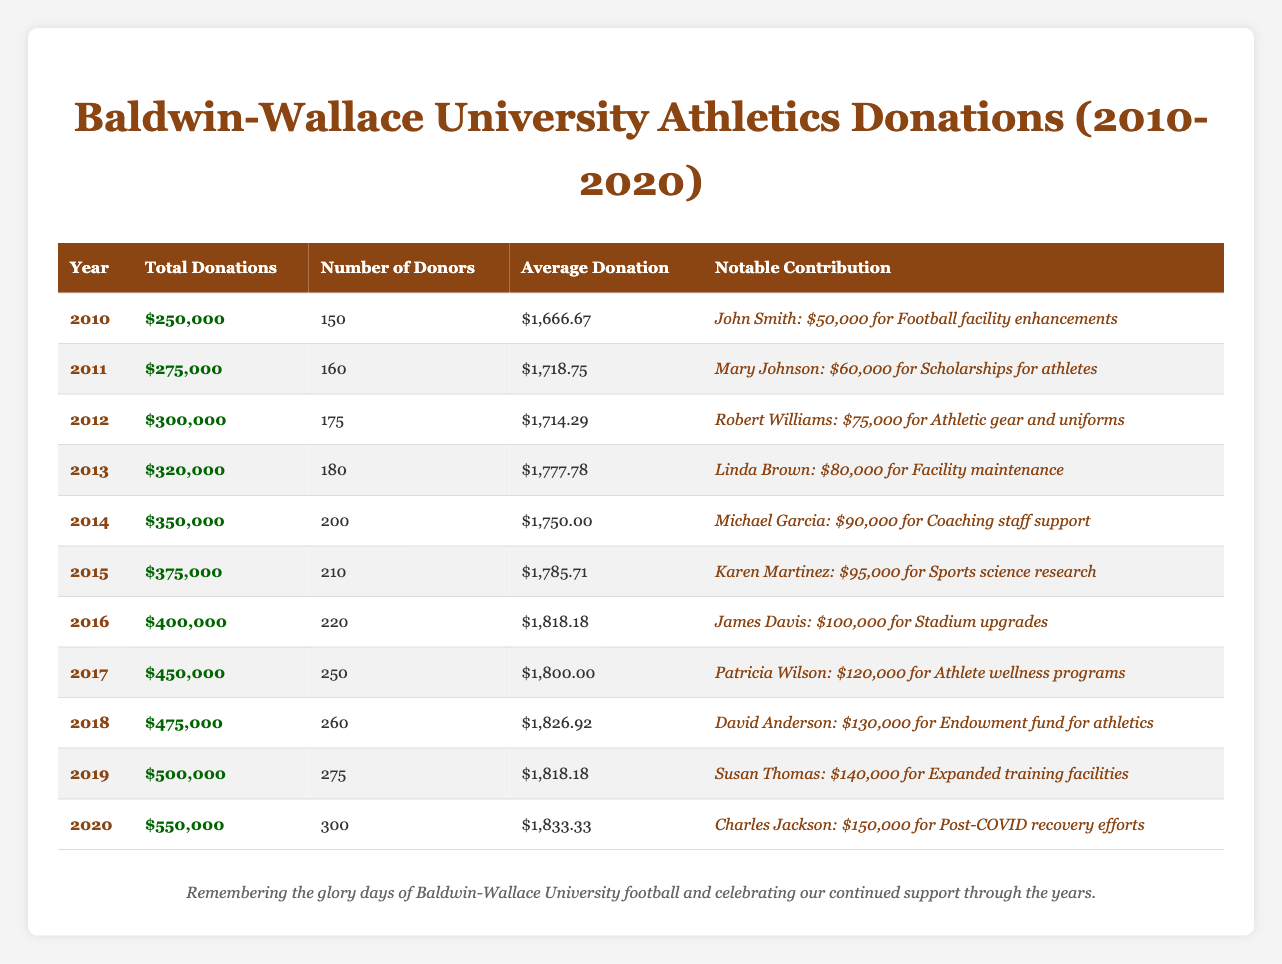What was the total donations in 2015? In the table, I find the row for the year 2015, where the total donations are listed as $375,000.
Answer: $375,000 Which year had the highest average donation amount? I look at the "Average Donation" column and compare the values. The highest average donation is $1,833.33 in 2020.
Answer: $1,833.33 How much did alumni donate in total from 2010 to 2014? I sum the total donations from the years 2010 to 2014: $250,000 + $275,000 + $300,000 + $320,000 + $350,000 = $1,495,000.
Answer: $1,495,000 Was there an increase in the number of donors from 2011 to 2012? I compare the number of donors in 2011, which is 160, and in 2012, which is 175. Since 175 is greater than 160, it indicates an increase.
Answer: Yes What was the total donations in 2019, and who made the notable contribution that year? Referring to the year 2019 in the table, the total donations were $500,000, and the notable contribution was made by Susan Thomas for $140,000.
Answer: $500,000, Susan Thomas Calculate the average number of donors from 2016 to 2020. I take the number of donors from 2016 to 2020: 220, 250, 260, 275, 300. I sum these: 220 + 250 + 260 + 275 + 300 = 1305. Then, I divide by 5: 1305 / 5 = 261.
Answer: 261 Which year had the least total donations, and what was the amount? I search through the total donations column and find that 2010 had the least total donations at $250,000.
Answer: 2010, $250,000 What percentage increase in total donations occurred from 2018 to 2020? I find the total donations for 2018, which is $475,000, and for 2020, which is $550,000. I calculate the increase: $550,000 - $475,000 = $75,000. The percentage increase is ($75,000 / $475,000) * 100 ≈ 15.79%.
Answer: Approximately 15.79% What notable contribution was made for coaching staff support, and who was the donor? Referring to the year 2014 in the table, the notable contribution for coaching staff support was made by Michael Garcia, amounting to $90,000.
Answer: Michael Garcia, $90,000 How much more in total donations did Baldwin-Wallace University receive in 2020 compared to 2010? I subtract the total donations of 2010 ($250,000) from those of 2020 ($550,000): $550,000 - $250,000 = $300,000.
Answer: $300,000 